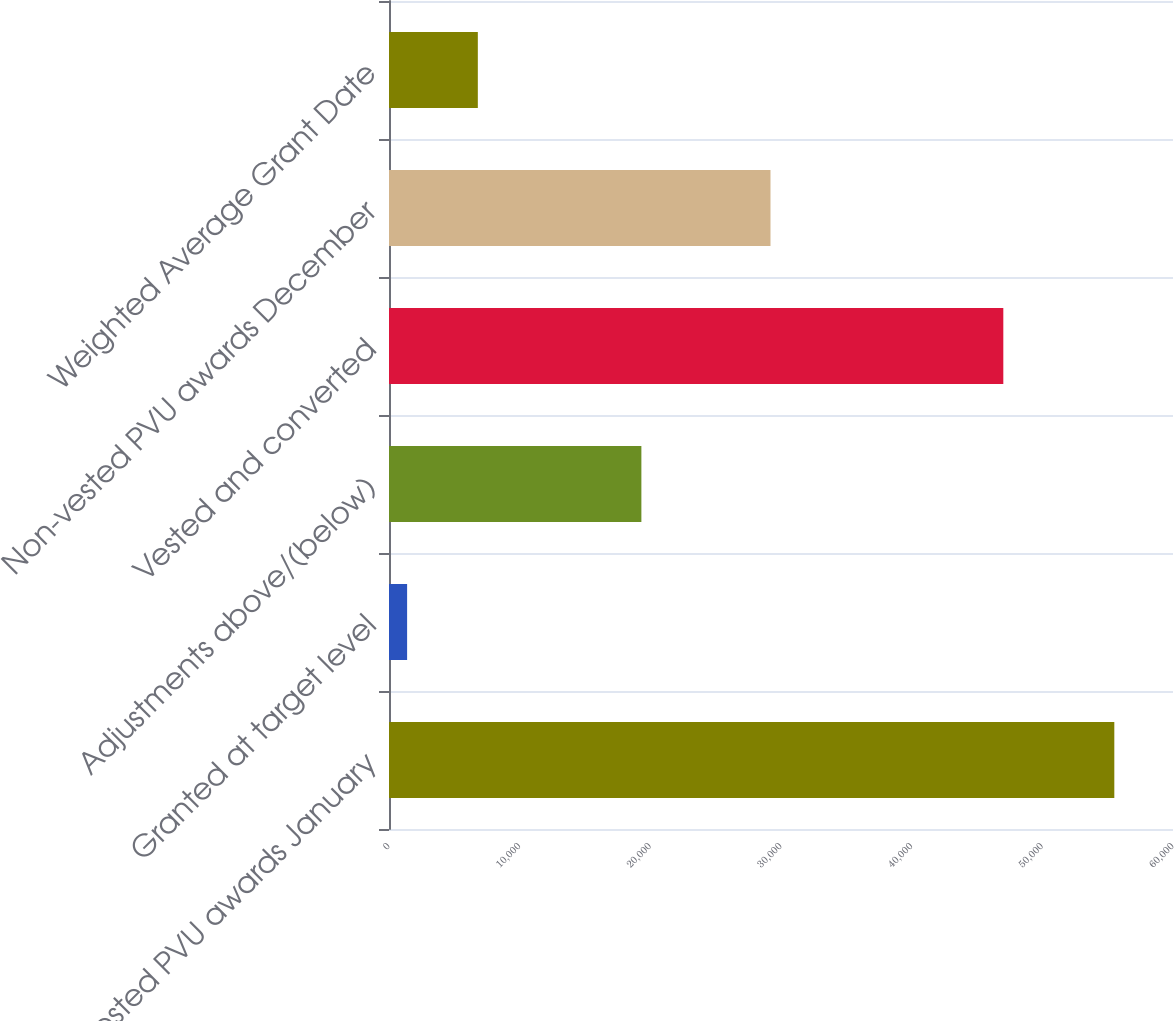<chart> <loc_0><loc_0><loc_500><loc_500><bar_chart><fcel>Non-vested PVU awards January<fcel>Granted at target level<fcel>Adjustments above/(below)<fcel>Vested and converted<fcel>Non-vested PVU awards December<fcel>Weighted Average Grant Date<nl><fcel>55509<fcel>1386<fcel>19315<fcel>47014<fcel>29196<fcel>6798.3<nl></chart> 